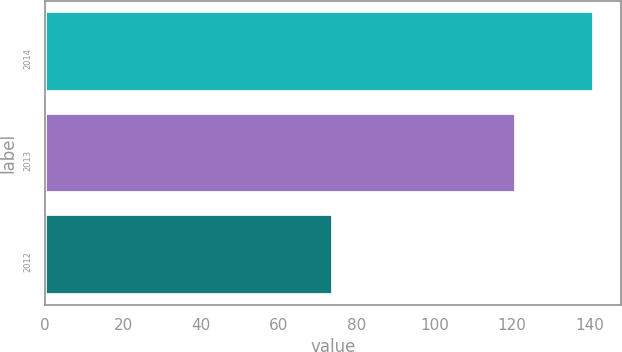Convert chart to OTSL. <chart><loc_0><loc_0><loc_500><loc_500><bar_chart><fcel>2014<fcel>2013<fcel>2012<nl><fcel>141<fcel>121<fcel>74<nl></chart> 